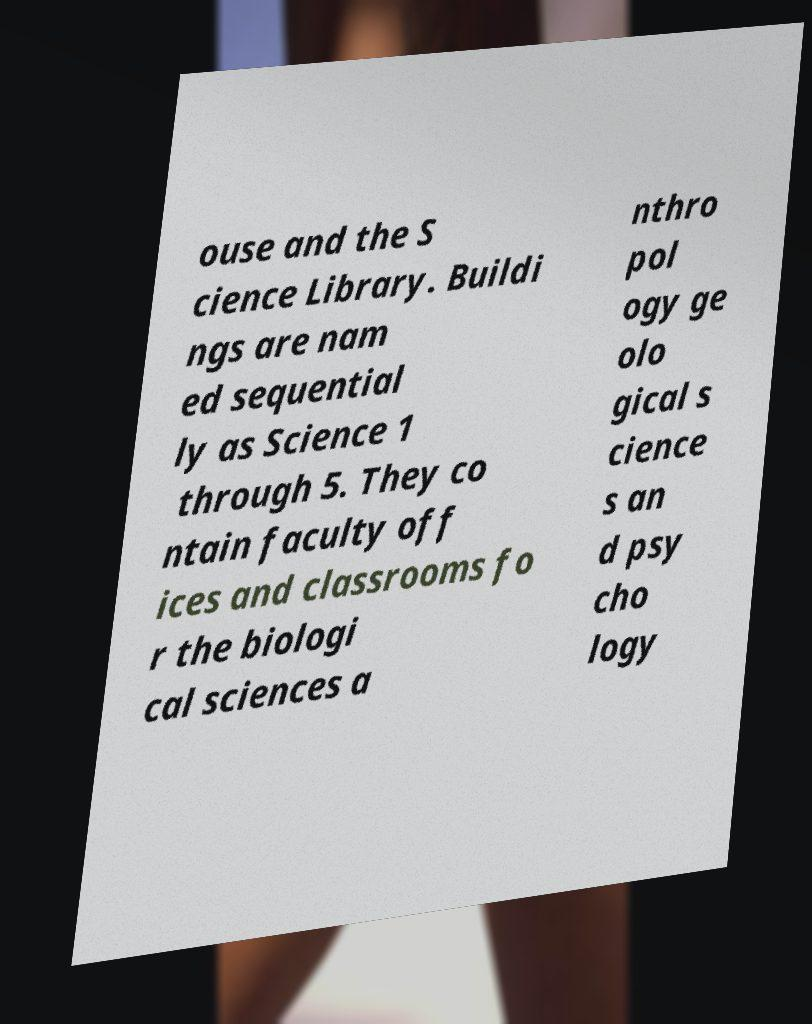For documentation purposes, I need the text within this image transcribed. Could you provide that? ouse and the S cience Library. Buildi ngs are nam ed sequential ly as Science 1 through 5. They co ntain faculty off ices and classrooms fo r the biologi cal sciences a nthro pol ogy ge olo gical s cience s an d psy cho logy 